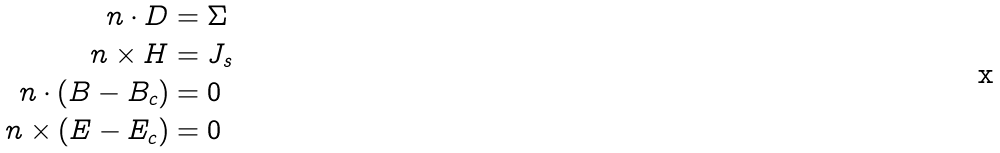Convert formula to latex. <formula><loc_0><loc_0><loc_500><loc_500>n \cdot D & = \Sigma \\ n \times H & = J _ { s } \\ n \cdot ( B - B _ { c } ) & = 0 \\ n \times ( E - E _ { c } ) & = 0</formula> 